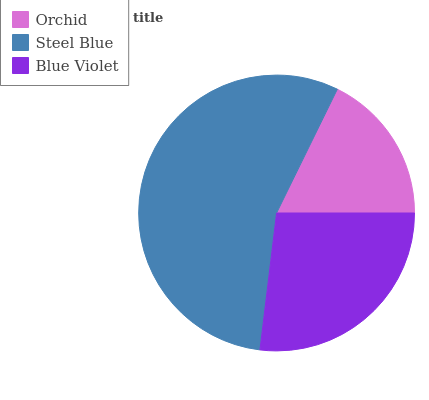Is Orchid the minimum?
Answer yes or no. Yes. Is Steel Blue the maximum?
Answer yes or no. Yes. Is Blue Violet the minimum?
Answer yes or no. No. Is Blue Violet the maximum?
Answer yes or no. No. Is Steel Blue greater than Blue Violet?
Answer yes or no. Yes. Is Blue Violet less than Steel Blue?
Answer yes or no. Yes. Is Blue Violet greater than Steel Blue?
Answer yes or no. No. Is Steel Blue less than Blue Violet?
Answer yes or no. No. Is Blue Violet the high median?
Answer yes or no. Yes. Is Blue Violet the low median?
Answer yes or no. Yes. Is Orchid the high median?
Answer yes or no. No. Is Steel Blue the low median?
Answer yes or no. No. 